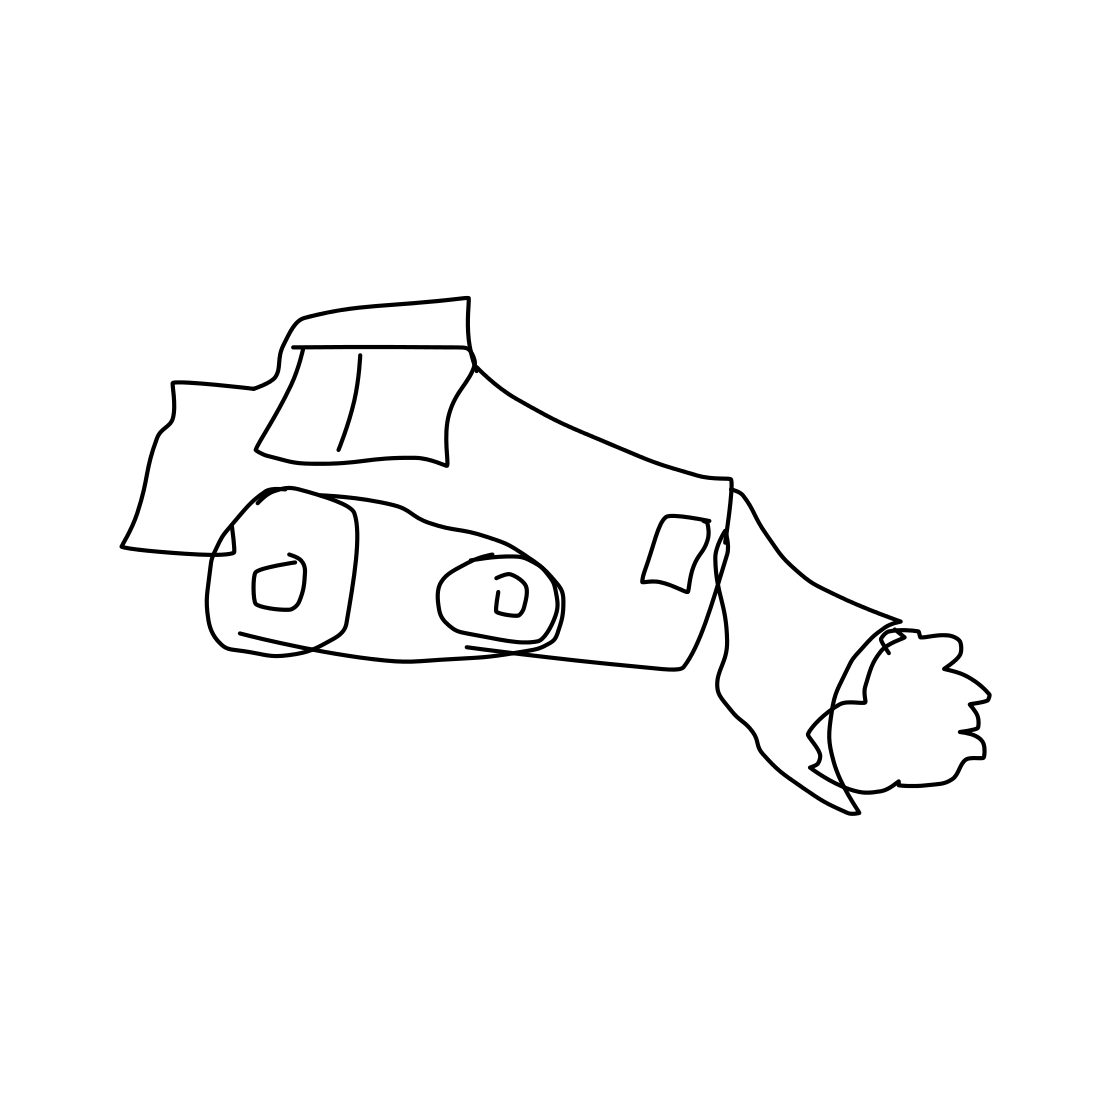Is there a sketchy grapes in the picture? The image does not contain any grapes, sketchy or otherwise. It is a simple line drawing of a vehicle, possibly a racing car, seen from a side perspective. 